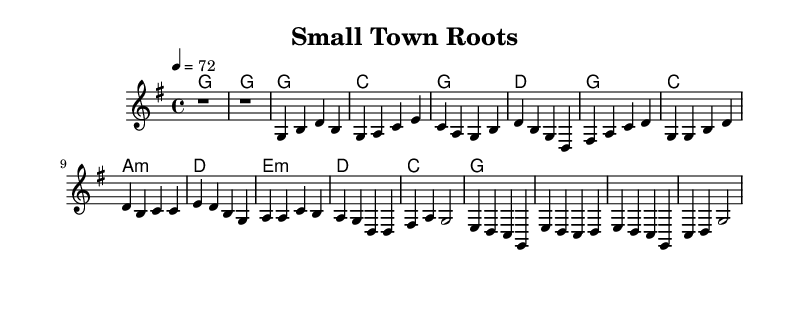What is the key signature of this music? The key signature is G major, which has one sharp (F#). This can be determined by looking at the key signature symbol at the beginning of the music, which indicates the notes that are sharp in the piece.
Answer: G major What is the time signature of this piece? The time signature is 4/4, which is indicated at the beginning of the score. This means there are four beats in a measure and the quarter note gets one beat.
Answer: 4/4 What is the tempo marking of this music? The tempo marking is 72 beats per minute, which is found in the tempo indication at the start of the score. It provides the speed for the music.
Answer: 72 How many measures are there in the chorus section? There are six measures in the chorus section. This can be counted by identifying the measures from the start of the chorus to the end, separating each one visually on the staff.
Answer: 6 What is the chord for the first measure of the verse? The chord for the first measure of the verse is G major. This can be determined by looking at the chord symbols above the staff where it states the harmony for that measure.
Answer: G What is the lyric line associated with the melody in the chorus? The lyric line associated with the melody in the chorus begins with "Small town roots, run deep and true." This is found underneath the melody notes for the chorus section, aligning with the corresponding notes.
Answer: Small town roots, run deep and true What is the overall theme expressed in the lyrics? The overall theme expressed in the lyrics is about community and belonging in a small town. This can be inferred from the repeated references to 'small town,' 'roots,' and a sense of welcome in the lyrics presented.
Answer: Community and belonging 